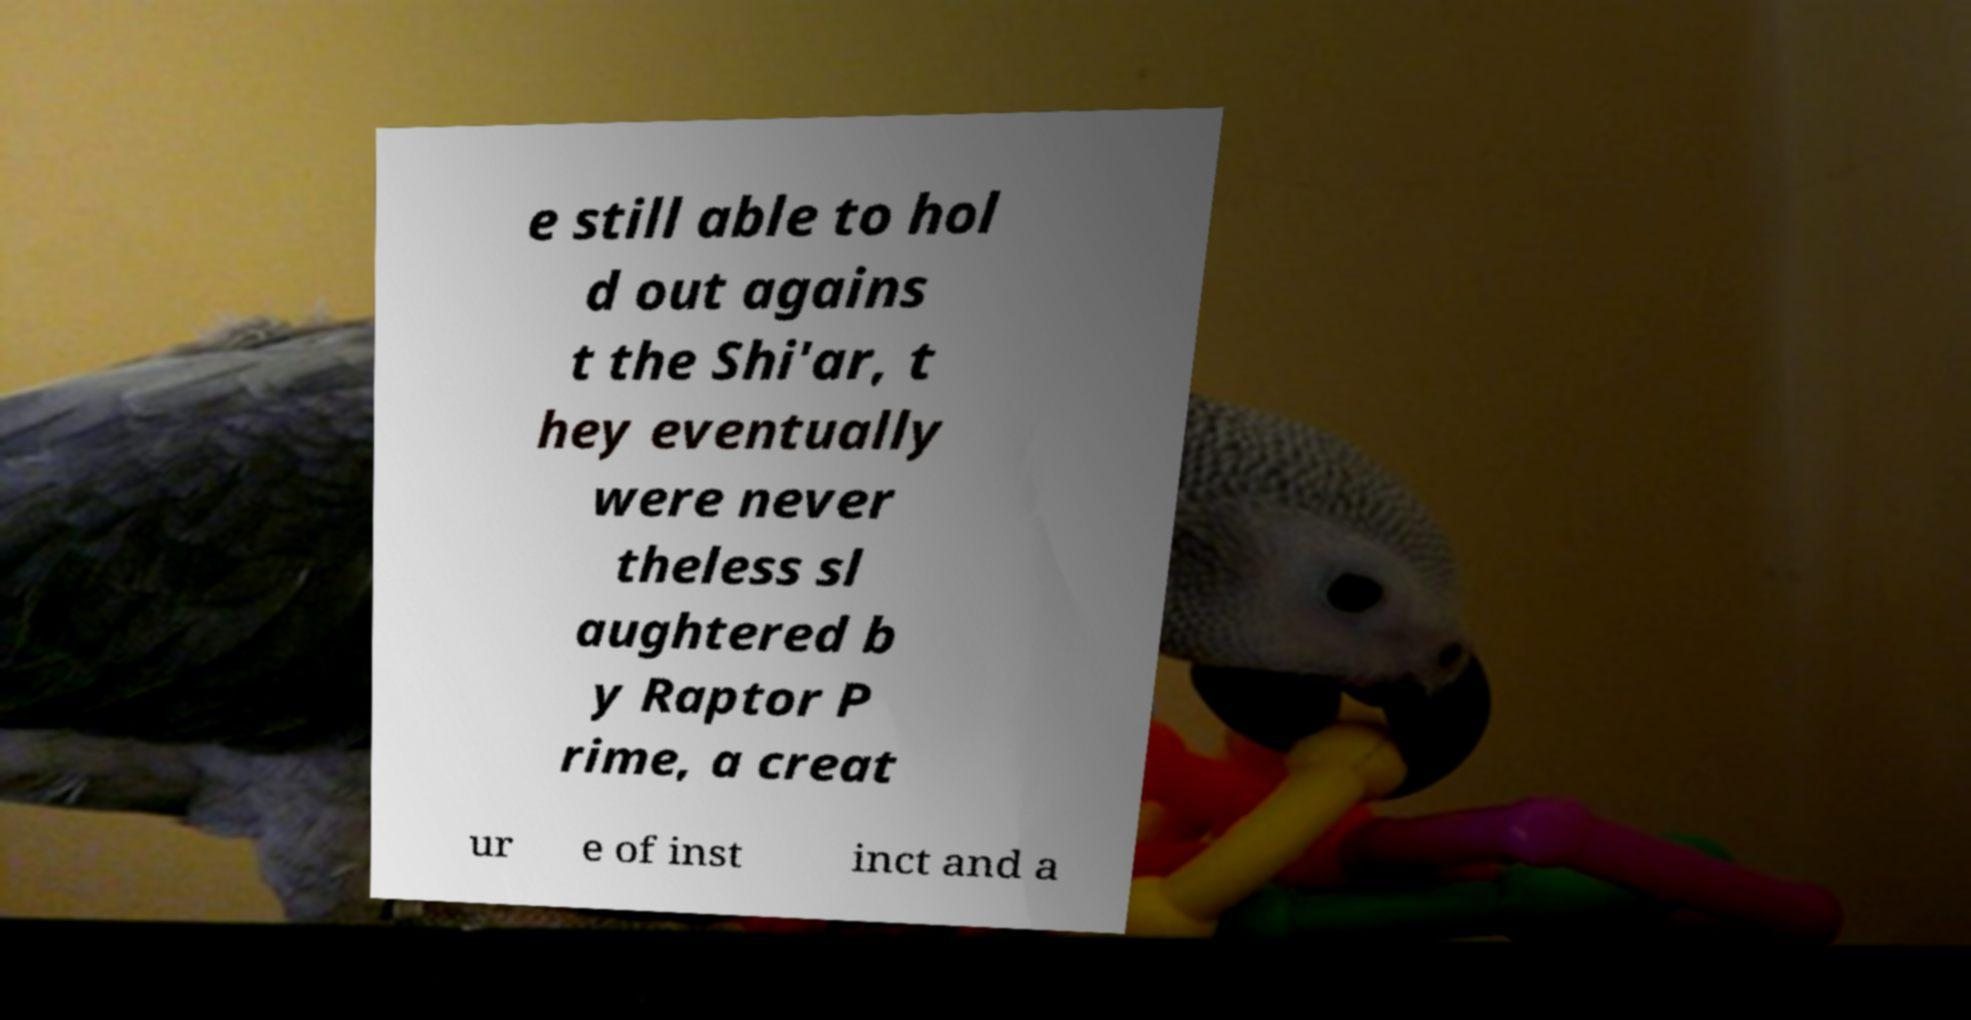Can you accurately transcribe the text from the provided image for me? e still able to hol d out agains t the Shi'ar, t hey eventually were never theless sl aughtered b y Raptor P rime, a creat ur e of inst inct and a 